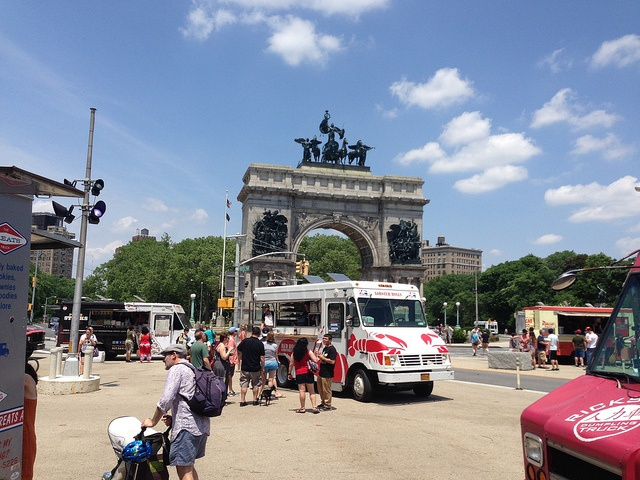Describe the objects in this image and their specific colors. I can see truck in darkgray, white, black, and gray tones, truck in darkgray, salmon, black, maroon, and white tones, people in darkgray, black, gray, and maroon tones, truck in darkgray, black, lightgray, and gray tones, and truck in darkgray, black, gray, beige, and maroon tones in this image. 